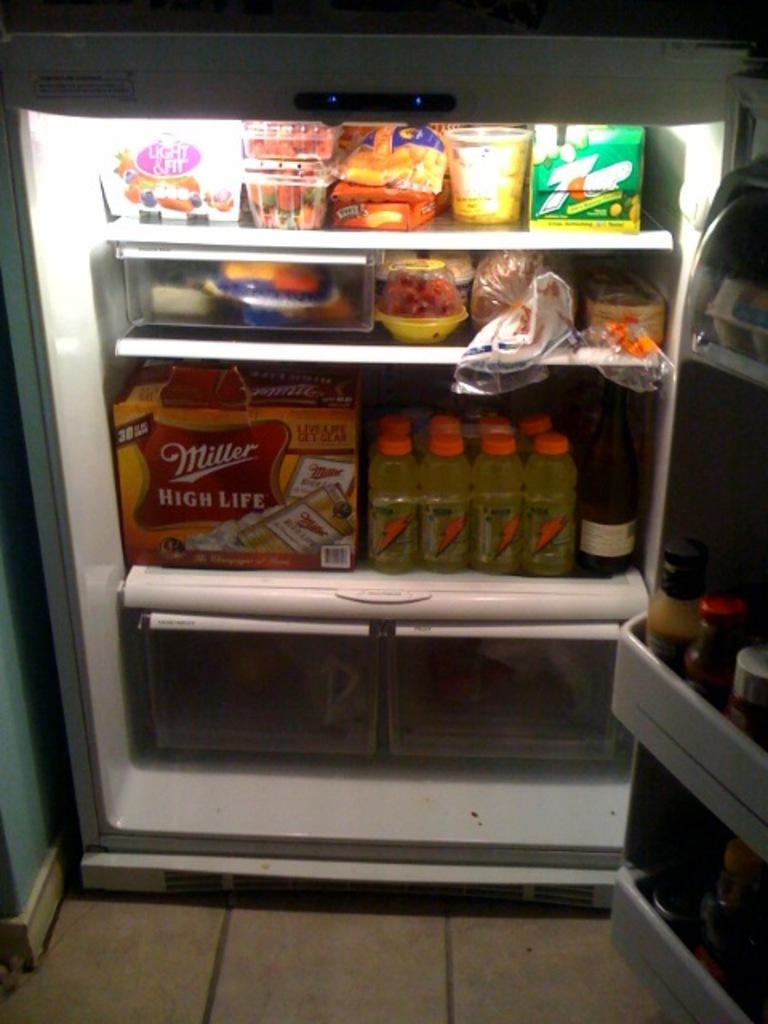Provide a one-sentence caption for the provided image. An open fridge reveals many drinks life Miller High Life and sports drinks. 